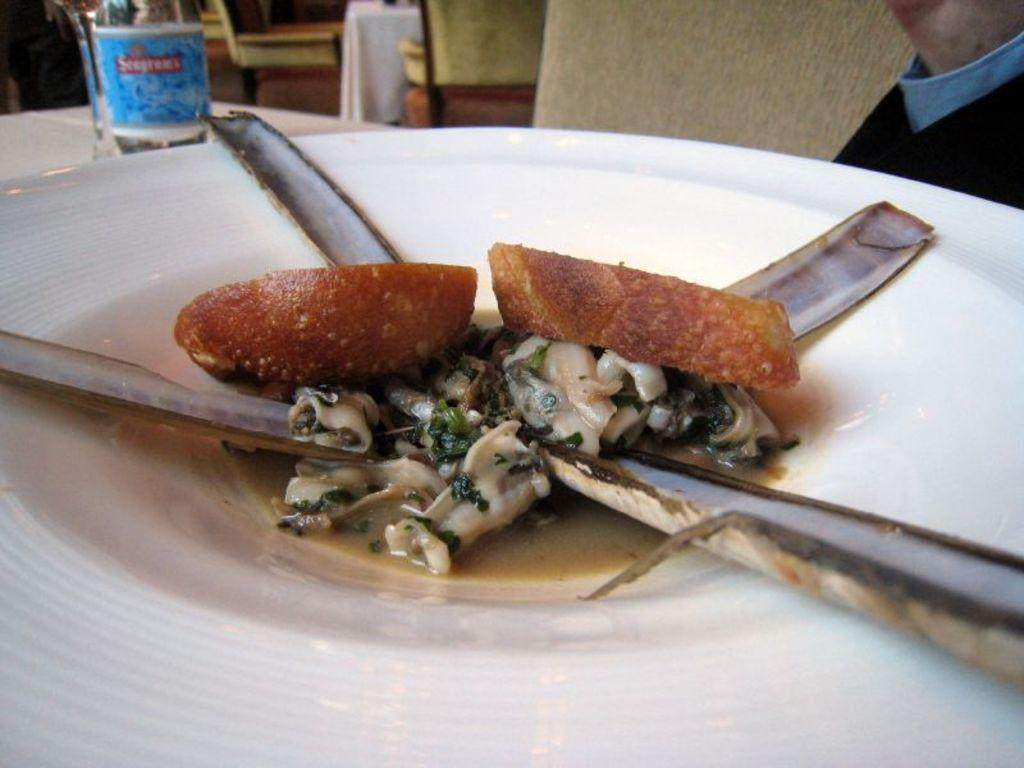What is on the plate that is visible in the image? There is a plate with food in the image. What else can be seen on the table in the image? There is a bottle on the table in the image. What type of furniture is present in the background of the image? Chairs are present in the background of the image. How much tax is being paid for the cakes in the image? There are no cakes present in the image, so it is not possible to determine the tax being paid. 